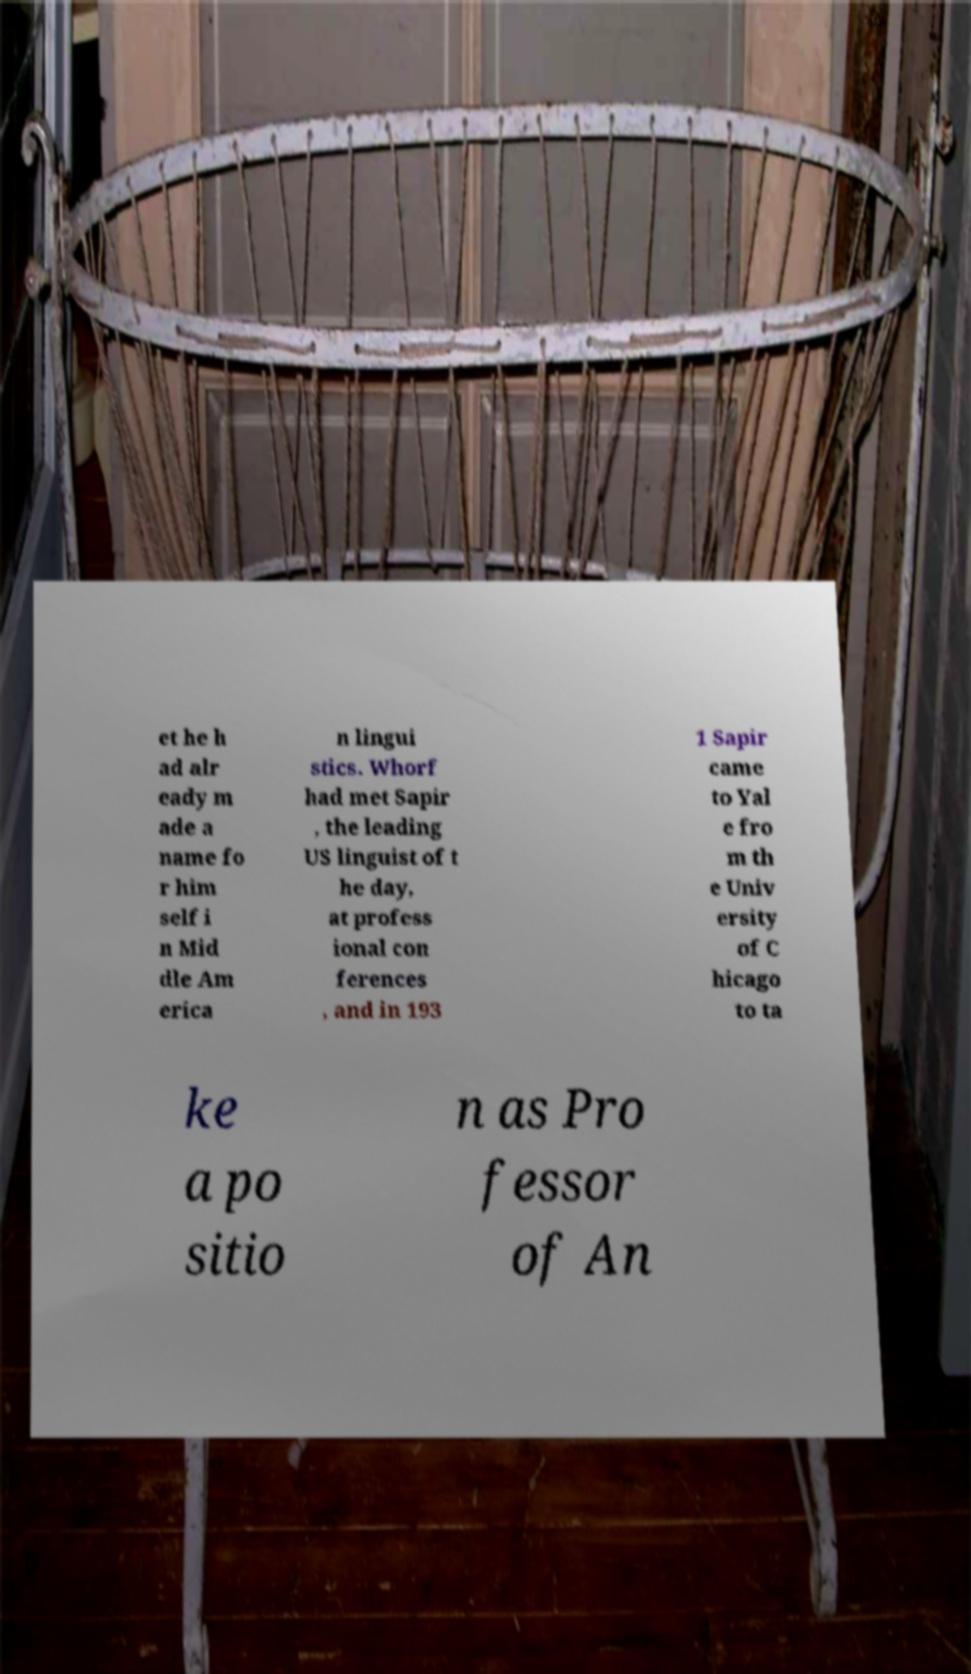Can you read and provide the text displayed in the image?This photo seems to have some interesting text. Can you extract and type it out for me? et he h ad alr eady m ade a name fo r him self i n Mid dle Am erica n lingui stics. Whorf had met Sapir , the leading US linguist of t he day, at profess ional con ferences , and in 193 1 Sapir came to Yal e fro m th e Univ ersity of C hicago to ta ke a po sitio n as Pro fessor of An 